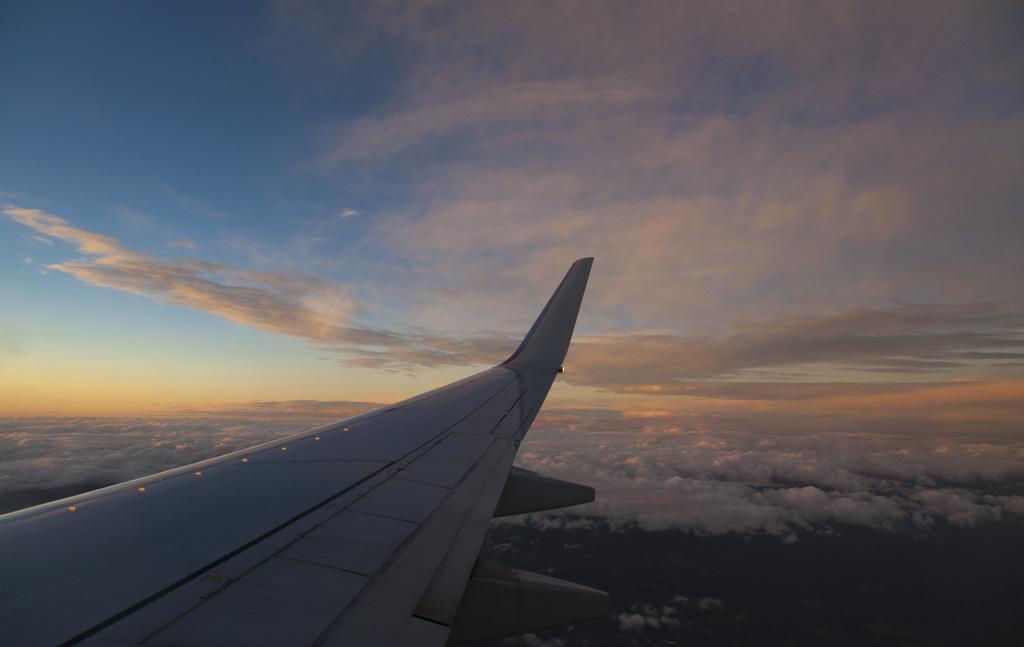In one or two sentences, can you explain what this image depicts? In the image we can see there is a side wing of an aeroplane. 